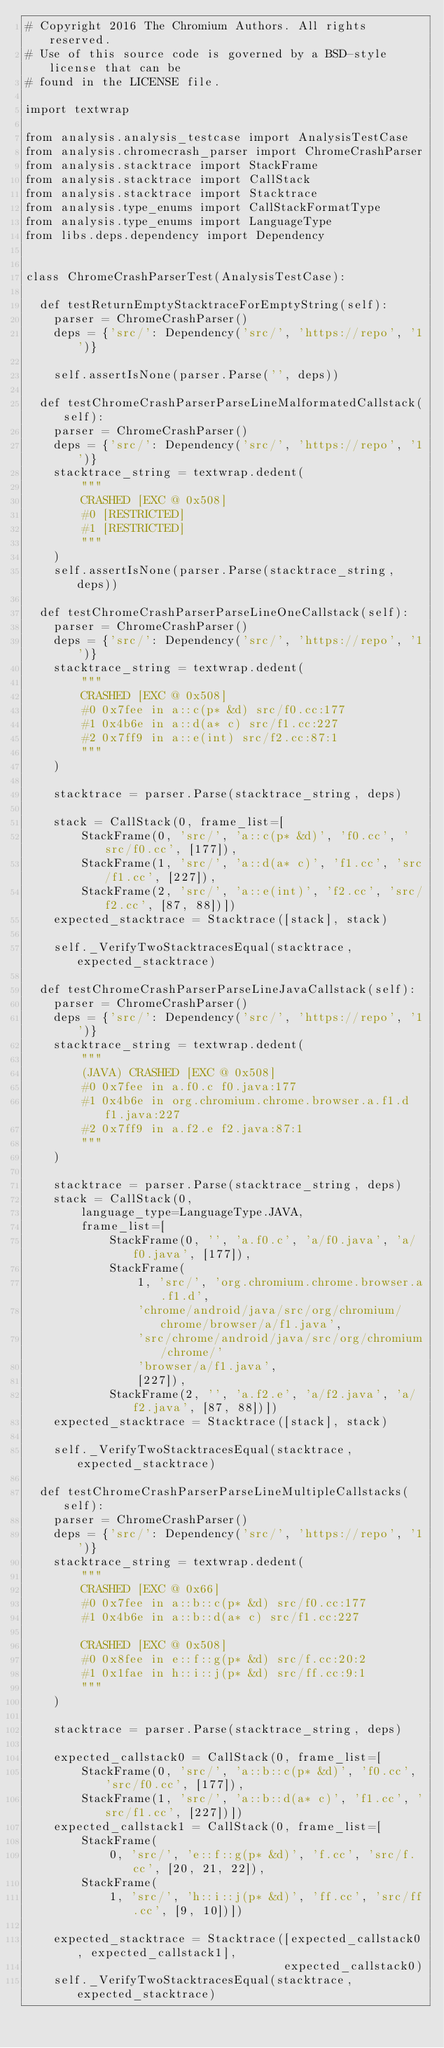Convert code to text. <code><loc_0><loc_0><loc_500><loc_500><_Python_># Copyright 2016 The Chromium Authors. All rights reserved.
# Use of this source code is governed by a BSD-style license that can be
# found in the LICENSE file.

import textwrap

from analysis.analysis_testcase import AnalysisTestCase
from analysis.chromecrash_parser import ChromeCrashParser
from analysis.stacktrace import StackFrame
from analysis.stacktrace import CallStack
from analysis.stacktrace import Stacktrace
from analysis.type_enums import CallStackFormatType
from analysis.type_enums import LanguageType
from libs.deps.dependency import Dependency


class ChromeCrashParserTest(AnalysisTestCase):

  def testReturnEmptyStacktraceForEmptyString(self):
    parser = ChromeCrashParser()
    deps = {'src/': Dependency('src/', 'https://repo', '1')}

    self.assertIsNone(parser.Parse('', deps))

  def testChromeCrashParserParseLineMalformatedCallstack(self):
    parser = ChromeCrashParser()
    deps = {'src/': Dependency('src/', 'https://repo', '1')}
    stacktrace_string = textwrap.dedent(
        """
        CRASHED [EXC @ 0x508]
        #0 [RESTRICTED]
        #1 [RESTRICTED]
        """
    )
    self.assertIsNone(parser.Parse(stacktrace_string, deps))

  def testChromeCrashParserParseLineOneCallstack(self):
    parser = ChromeCrashParser()
    deps = {'src/': Dependency('src/', 'https://repo', '1')}
    stacktrace_string = textwrap.dedent(
        """
        CRASHED [EXC @ 0x508]
        #0 0x7fee in a::c(p* &d) src/f0.cc:177
        #1 0x4b6e in a::d(a* c) src/f1.cc:227
        #2 0x7ff9 in a::e(int) src/f2.cc:87:1
        """
    )

    stacktrace = parser.Parse(stacktrace_string, deps)

    stack = CallStack(0, frame_list=[
        StackFrame(0, 'src/', 'a::c(p* &d)', 'f0.cc', 'src/f0.cc', [177]),
        StackFrame(1, 'src/', 'a::d(a* c)', 'f1.cc', 'src/f1.cc', [227]),
        StackFrame(2, 'src/', 'a::e(int)', 'f2.cc', 'src/f2.cc', [87, 88])])
    expected_stacktrace = Stacktrace([stack], stack)

    self._VerifyTwoStacktracesEqual(stacktrace, expected_stacktrace)

  def testChromeCrashParserParseLineJavaCallstack(self):
    parser = ChromeCrashParser()
    deps = {'src/': Dependency('src/', 'https://repo', '1')}
    stacktrace_string = textwrap.dedent(
        """
        (JAVA) CRASHED [EXC @ 0x508]
        #0 0x7fee in a.f0.c f0.java:177
        #1 0x4b6e in org.chromium.chrome.browser.a.f1.d f1.java:227
        #2 0x7ff9 in a.f2.e f2.java:87:1
        """
    )

    stacktrace = parser.Parse(stacktrace_string, deps)
    stack = CallStack(0,
        language_type=LanguageType.JAVA,
        frame_list=[
            StackFrame(0, '', 'a.f0.c', 'a/f0.java', 'a/f0.java', [177]),
            StackFrame(
                1, 'src/', 'org.chromium.chrome.browser.a.f1.d',
                'chrome/android/java/src/org/chromium/chrome/browser/a/f1.java',
                'src/chrome/android/java/src/org/chromium/chrome/'
                'browser/a/f1.java',
                [227]),
            StackFrame(2, '', 'a.f2.e', 'a/f2.java', 'a/f2.java', [87, 88])])
    expected_stacktrace = Stacktrace([stack], stack)

    self._VerifyTwoStacktracesEqual(stacktrace, expected_stacktrace)

  def testChromeCrashParserParseLineMultipleCallstacks(self):
    parser = ChromeCrashParser()
    deps = {'src/': Dependency('src/', 'https://repo', '1')}
    stacktrace_string = textwrap.dedent(
        """
        CRASHED [EXC @ 0x66]
        #0 0x7fee in a::b::c(p* &d) src/f0.cc:177
        #1 0x4b6e in a::b::d(a* c) src/f1.cc:227

        CRASHED [EXC @ 0x508]
        #0 0x8fee in e::f::g(p* &d) src/f.cc:20:2
        #1 0x1fae in h::i::j(p* &d) src/ff.cc:9:1
        """
    )

    stacktrace = parser.Parse(stacktrace_string, deps)

    expected_callstack0 = CallStack(0, frame_list=[
        StackFrame(0, 'src/', 'a::b::c(p* &d)', 'f0.cc', 'src/f0.cc', [177]),
        StackFrame(1, 'src/', 'a::b::d(a* c)', 'f1.cc', 'src/f1.cc', [227])])
    expected_callstack1 = CallStack(0, frame_list=[
        StackFrame(
            0, 'src/', 'e::f::g(p* &d)', 'f.cc', 'src/f.cc', [20, 21, 22]),
        StackFrame(
            1, 'src/', 'h::i::j(p* &d)', 'ff.cc', 'src/ff.cc', [9, 10])])

    expected_stacktrace = Stacktrace([expected_callstack0, expected_callstack1],
                                     expected_callstack0)
    self._VerifyTwoStacktracesEqual(stacktrace, expected_stacktrace)
</code> 